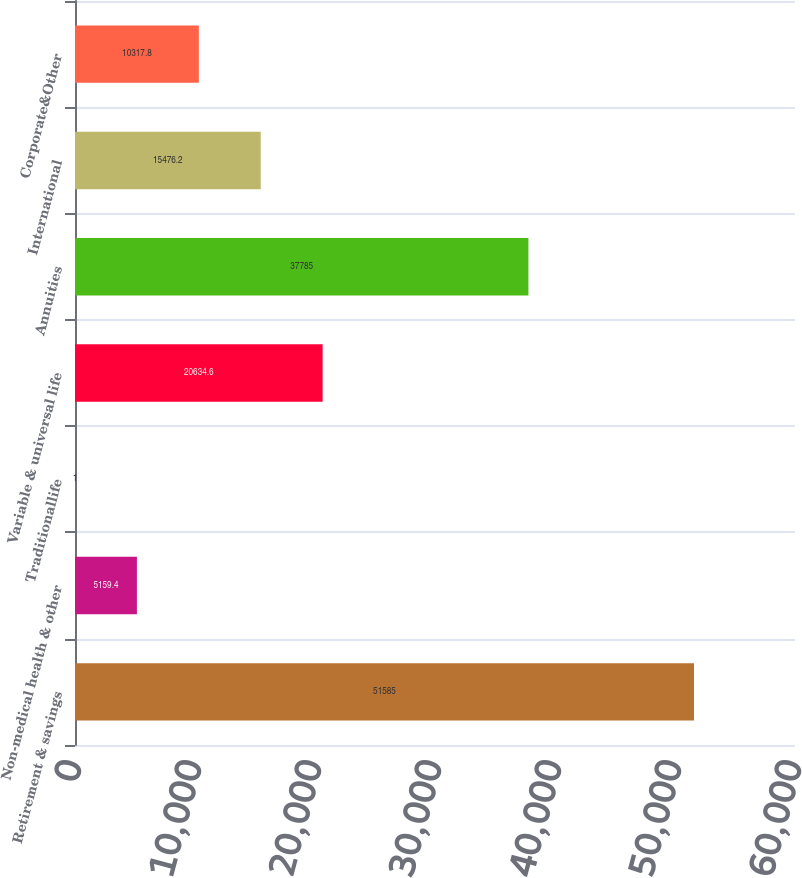<chart> <loc_0><loc_0><loc_500><loc_500><bar_chart><fcel>Retirement & savings<fcel>Non-medical health & other<fcel>Traditionallife<fcel>Variable & universal life<fcel>Annuities<fcel>International<fcel>Corporate&Other<nl><fcel>51585<fcel>5159.4<fcel>1<fcel>20634.6<fcel>37785<fcel>15476.2<fcel>10317.8<nl></chart> 